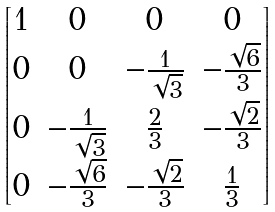Convert formula to latex. <formula><loc_0><loc_0><loc_500><loc_500>\begin{bmatrix} 1 & 0 & 0 & 0 \\ 0 & 0 & - \frac { 1 } { \sqrt { 3 } } & - \frac { \sqrt { 6 } } { 3 } \\ 0 & - \frac { 1 } { \sqrt { 3 } } & \frac { 2 } { 3 } & - \frac { \sqrt { 2 } } { 3 } \\ 0 & - \frac { \sqrt { 6 } } { 3 } & - \frac { \sqrt { 2 } } { 3 } & \frac { 1 } { 3 } \end{bmatrix}</formula> 